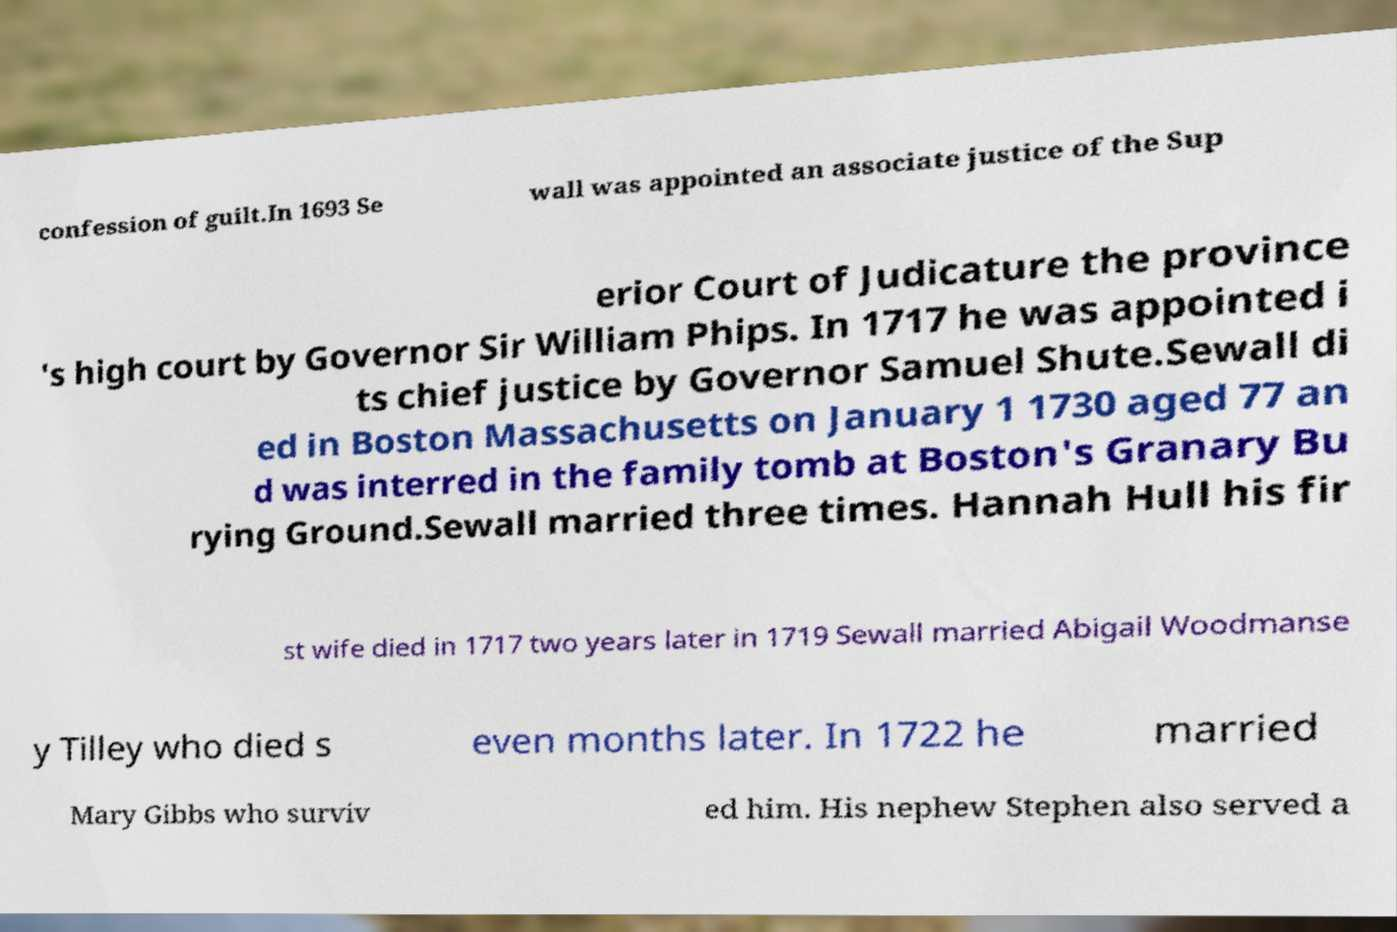I need the written content from this picture converted into text. Can you do that? confession of guilt.In 1693 Se wall was appointed an associate justice of the Sup erior Court of Judicature the province 's high court by Governor Sir William Phips. In 1717 he was appointed i ts chief justice by Governor Samuel Shute.Sewall di ed in Boston Massachusetts on January 1 1730 aged 77 an d was interred in the family tomb at Boston's Granary Bu rying Ground.Sewall married three times. Hannah Hull his fir st wife died in 1717 two years later in 1719 Sewall married Abigail Woodmanse y Tilley who died s even months later. In 1722 he married Mary Gibbs who surviv ed him. His nephew Stephen also served a 